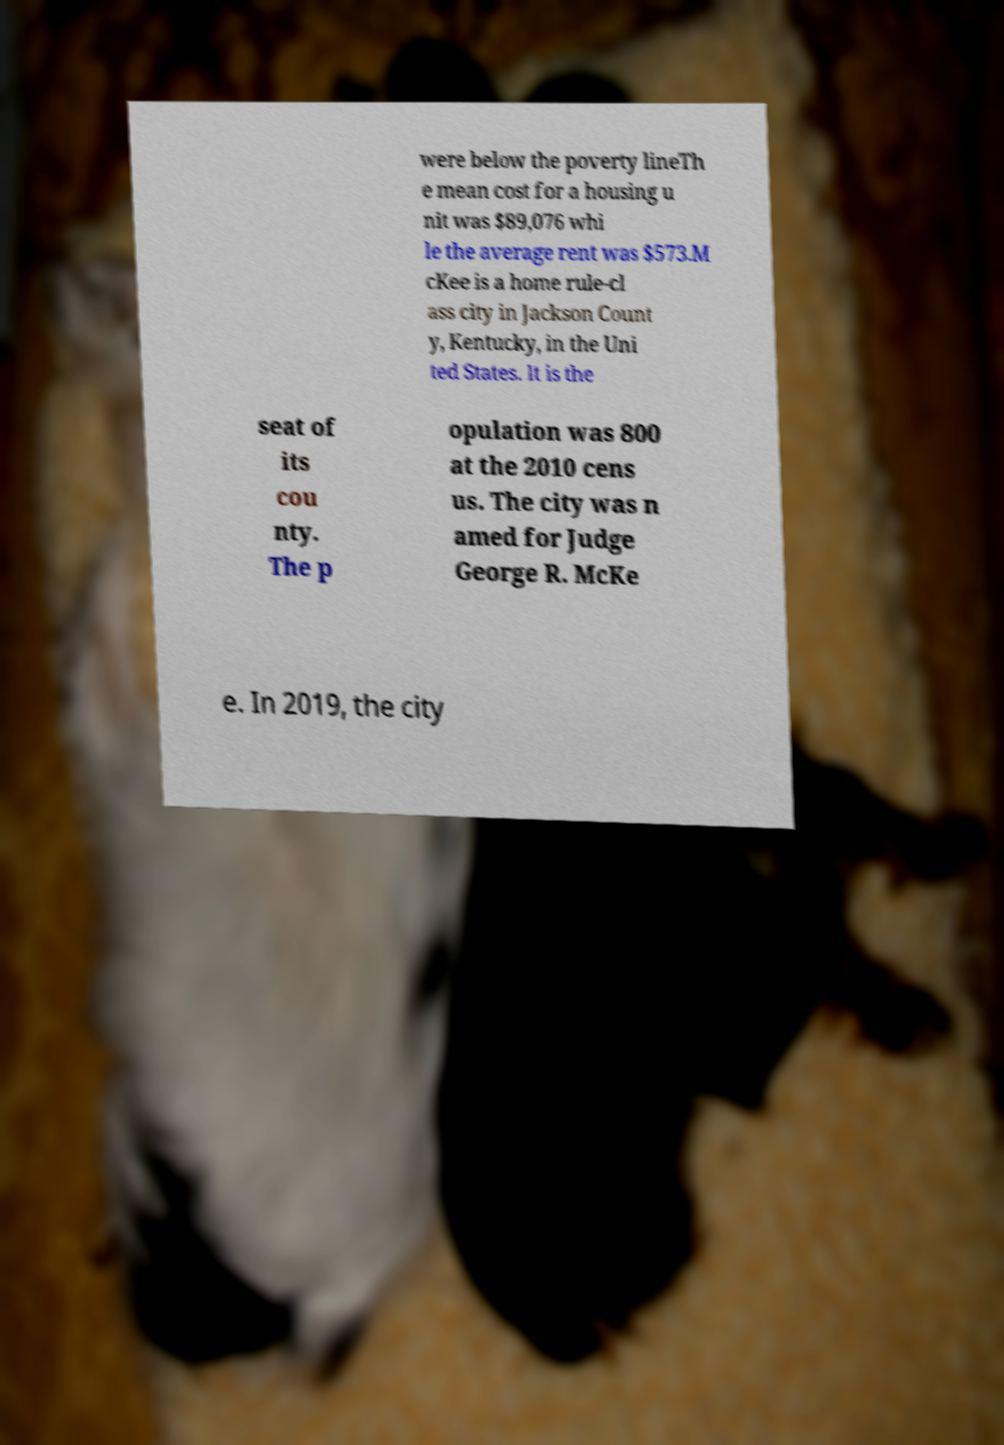Please identify and transcribe the text found in this image. were below the poverty lineTh e mean cost for a housing u nit was $89,076 whi le the average rent was $573.M cKee is a home rule-cl ass city in Jackson Count y, Kentucky, in the Uni ted States. It is the seat of its cou nty. The p opulation was 800 at the 2010 cens us. The city was n amed for Judge George R. McKe e. In 2019, the city 